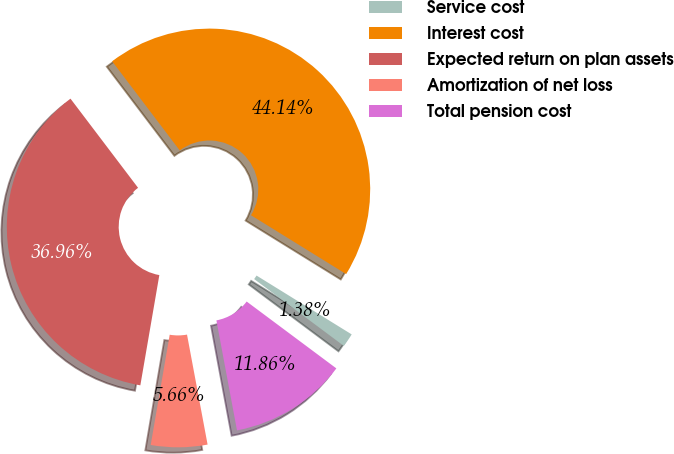Convert chart. <chart><loc_0><loc_0><loc_500><loc_500><pie_chart><fcel>Service cost<fcel>Interest cost<fcel>Expected return on plan assets<fcel>Amortization of net loss<fcel>Total pension cost<nl><fcel>1.38%<fcel>44.14%<fcel>36.96%<fcel>5.66%<fcel>11.86%<nl></chart> 